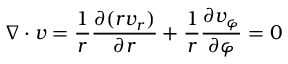Convert formula to latex. <formula><loc_0><loc_0><loc_500><loc_500>\nabla \cdot v = \frac { 1 } { r } \frac { \partial ( r v _ { r } ) } { \partial r } + \frac { 1 } { r } \frac { \partial v _ { \varphi } } { \partial \varphi } = 0</formula> 